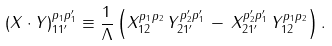Convert formula to latex. <formula><loc_0><loc_0><loc_500><loc_500>( X \cdot Y ) ^ { p _ { 1 } p _ { 1 } ^ { \prime } } _ { 1 1 ^ { \prime } } \equiv \frac { 1 } { \Lambda } \left ( X ^ { p _ { 1 } p _ { 2 } } _ { 1 2 } \, Y ^ { p _ { 2 } ^ { \prime } p _ { 1 } ^ { \prime } } _ { 2 1 ^ { \prime } } \, - \, X ^ { p _ { 2 } ^ { \prime } p _ { 1 } ^ { \prime } } _ { 2 1 ^ { \prime } } \, Y ^ { p _ { 1 } p _ { 2 } } _ { 1 2 } \right ) .</formula> 